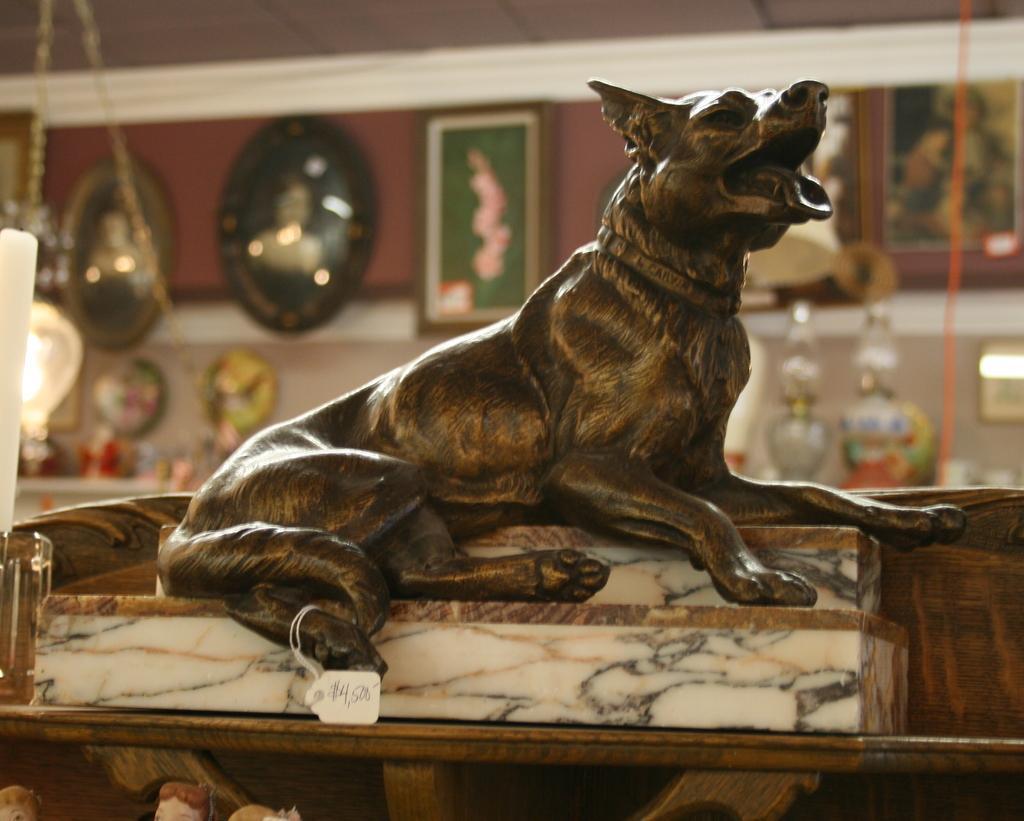Describe this image in one or two sentences. In this image in the front there is a statue. In the background there are frames on the wall and there are objects in front of the wall and there are lights. In the front there are toys. 